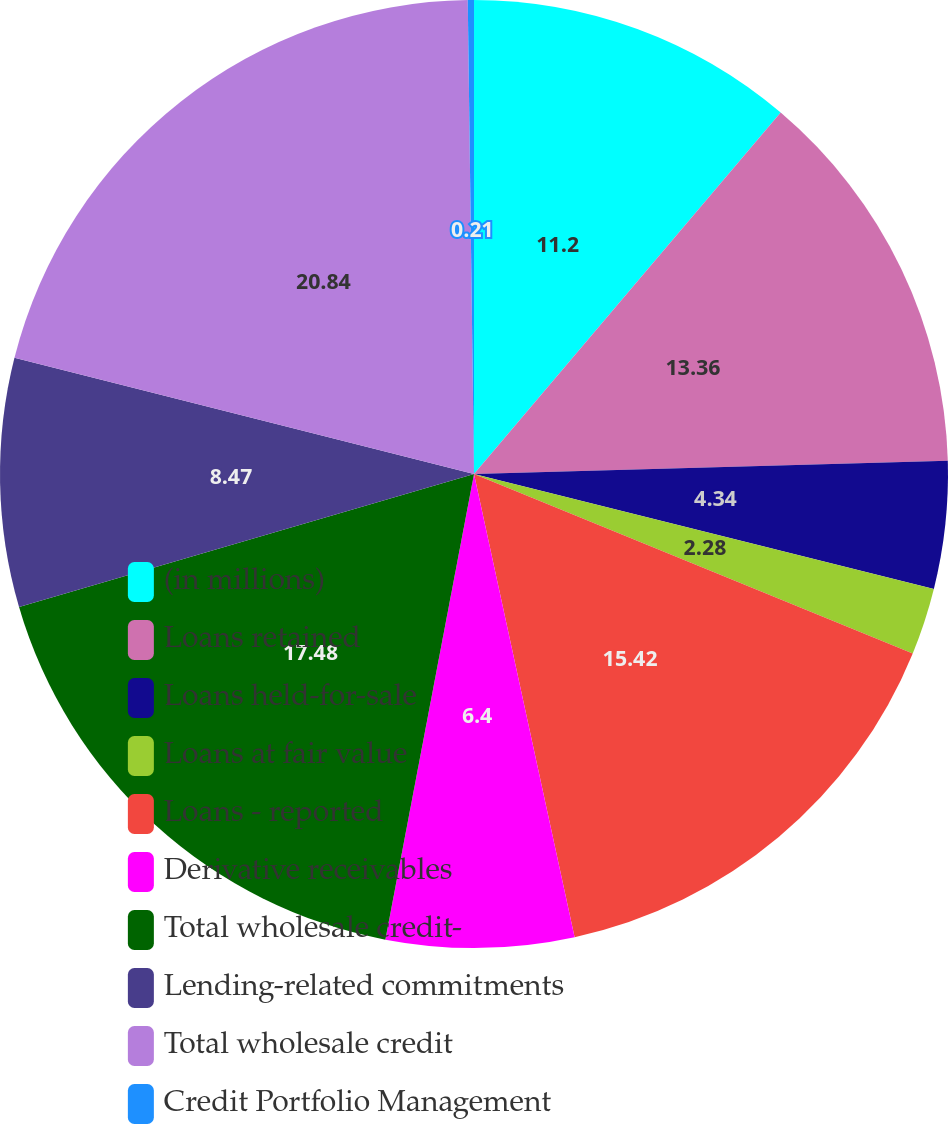Convert chart. <chart><loc_0><loc_0><loc_500><loc_500><pie_chart><fcel>(in millions)<fcel>Loans retained<fcel>Loans held-for-sale<fcel>Loans at fair value<fcel>Loans - reported<fcel>Derivative receivables<fcel>Total wholesale credit-<fcel>Lending-related commitments<fcel>Total wholesale credit<fcel>Credit Portfolio Management<nl><fcel>11.2%<fcel>13.36%<fcel>4.34%<fcel>2.28%<fcel>15.42%<fcel>6.4%<fcel>17.48%<fcel>8.47%<fcel>20.85%<fcel>0.21%<nl></chart> 